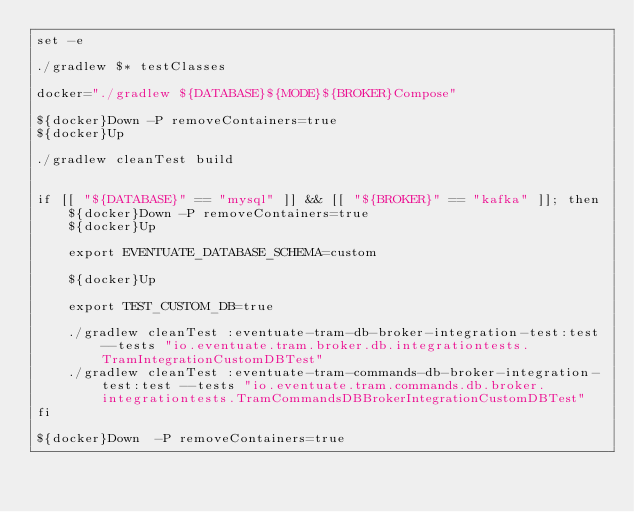<code> <loc_0><loc_0><loc_500><loc_500><_Bash_>set -e

./gradlew $* testClasses

docker="./gradlew ${DATABASE}${MODE}${BROKER}Compose"

${docker}Down -P removeContainers=true
${docker}Up

./gradlew cleanTest build


if [[ "${DATABASE}" == "mysql" ]] && [[ "${BROKER}" == "kafka" ]]; then
    ${docker}Down -P removeContainers=true
    ${docker}Up

    export EVENTUATE_DATABASE_SCHEMA=custom

    ${docker}Up

    export TEST_CUSTOM_DB=true

    ./gradlew cleanTest :eventuate-tram-db-broker-integration-test:test --tests "io.eventuate.tram.broker.db.integrationtests.TramIntegrationCustomDBTest"
    ./gradlew cleanTest :eventuate-tram-commands-db-broker-integration-test:test --tests "io.eventuate.tram.commands.db.broker.integrationtests.TramCommandsDBBrokerIntegrationCustomDBTest"
fi

${docker}Down  -P removeContainers=true
</code> 